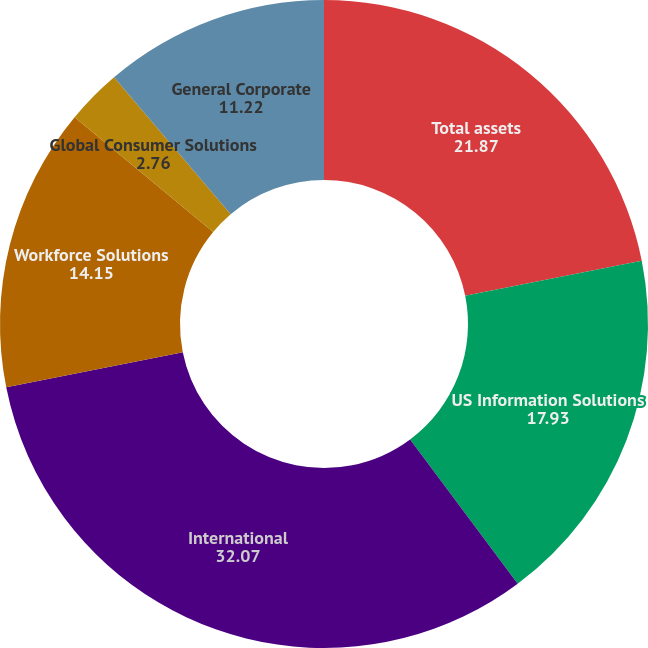<chart> <loc_0><loc_0><loc_500><loc_500><pie_chart><fcel>Total assets<fcel>US Information Solutions<fcel>International<fcel>Workforce Solutions<fcel>Global Consumer Solutions<fcel>General Corporate<nl><fcel>21.87%<fcel>17.93%<fcel>32.07%<fcel>14.15%<fcel>2.76%<fcel>11.22%<nl></chart> 